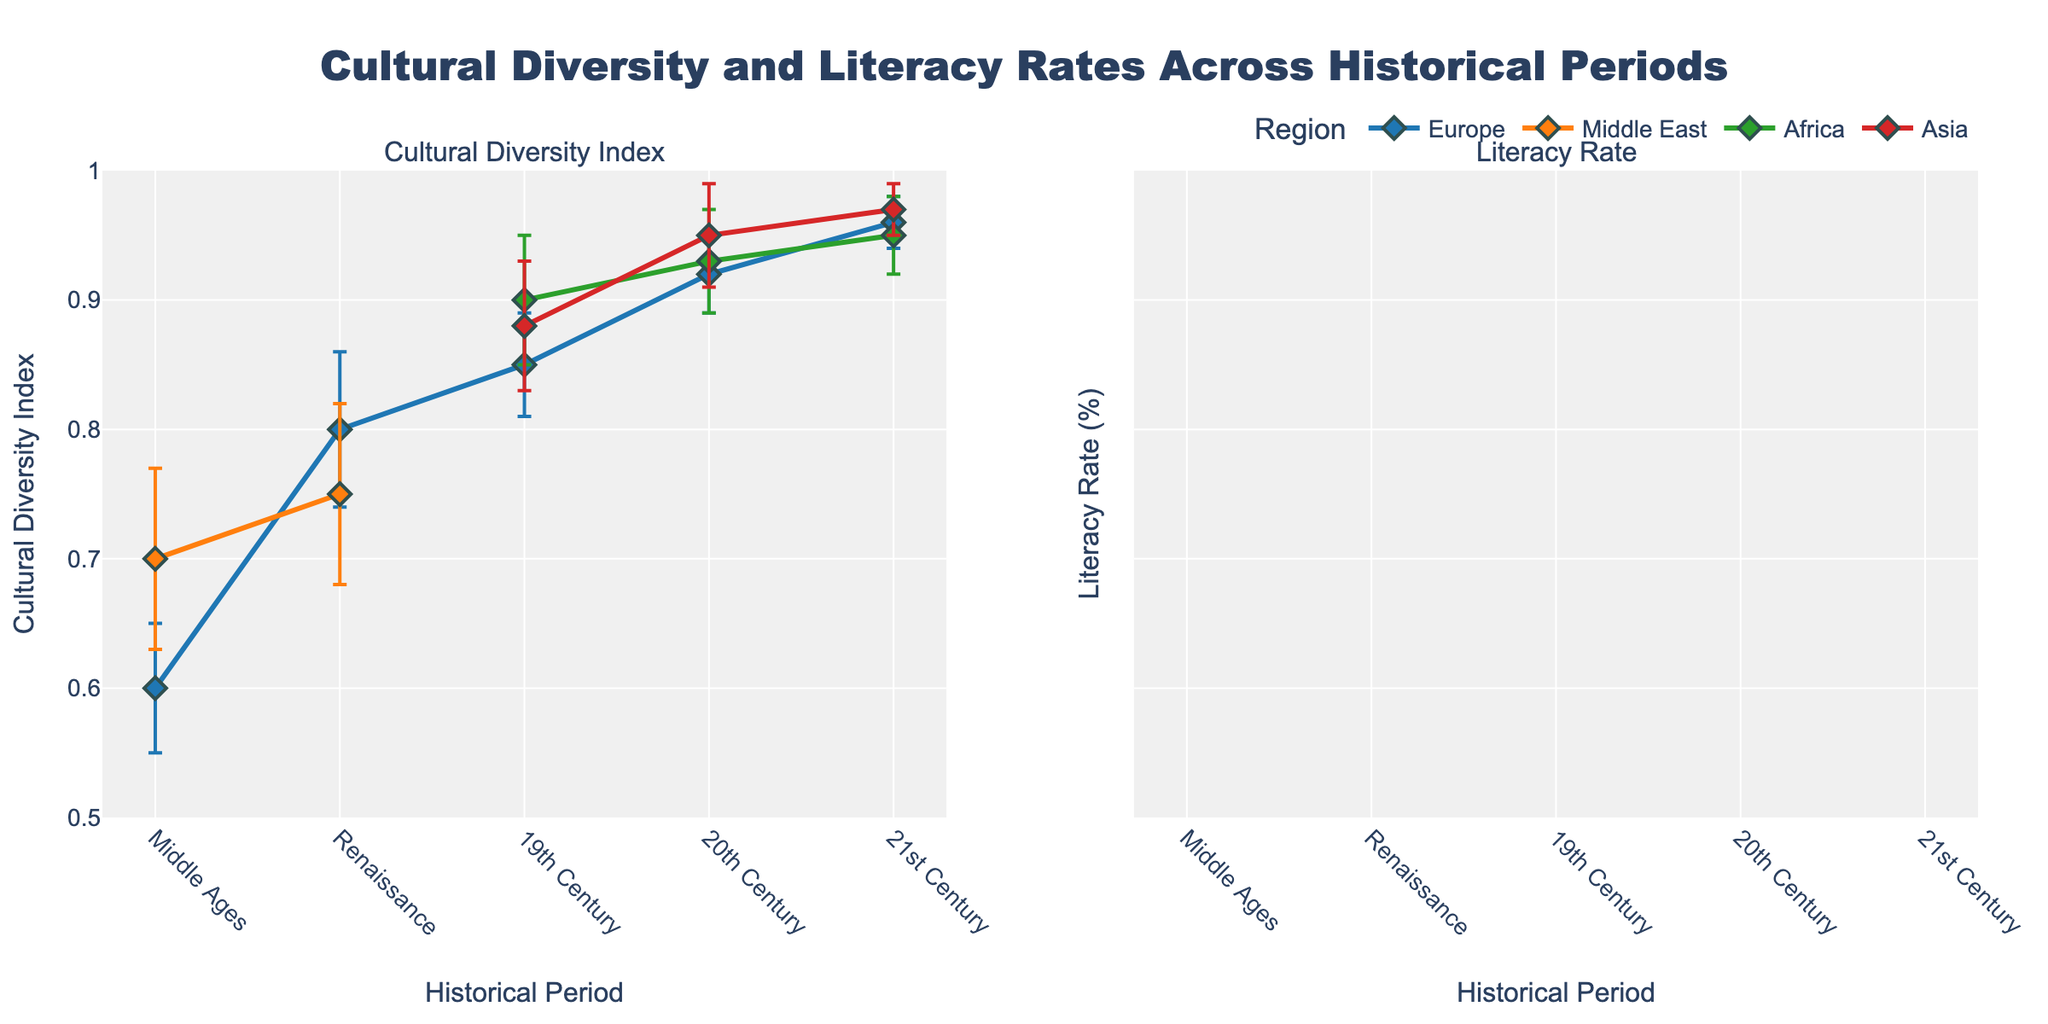Which historical period shows the highest Cultural Diversity Index for Europe? By observing the plot on the left, find the highest point for Europe (marked with a specific color and symbol). The 21st Century shows the highest point.
Answer: 21st Century What are the literacy rates for Asia in the 19th and 20th centuries? Look at the plot on the right, identify the two data points for Asia corresponding to the 19th and 20th centuries. The values are 30% and 65%, respectively.
Answer: 30%, 65% How does the Cultural Diversity Index of the Renaissance period in the Middle East compare to Europe? Examine the left subplot; identify the points for the Renaissance period for both regions. Europe has a CDI of 0.8, and the Middle East has a CDI of 0.75, indicating Europe has a slightly higher CDI.
Answer: Europe > Middle East What is the change in literacy rate for Africa from the 19th Century to the 20th Century? On the right plot, find the literacy rates for Africa in the 19th and 20th centuries. Subtract the 19th Century value (10%) from the 20th Century value (40%) to get the change.
Answer: 30% Which region has the highest error margin for the Literacy Rate in the 21st Century? In the right subplot, check the error bars for all regions in the 21st Century. Asia's error margin is the largest at 7.5.
Answer: Asia What is the average Cultural Diversity Index for Europe across all historical periods? Identify Europe's CDI values across all periods (0.6, 0.8, 0.85, 0.92, and 0.96). Calculate the average: (0.6 + 0.8 + 0.85 + 0.92 + 0.96) / 5.
Answer: 0.826 In which period did Asia show the greatest increase in literacy rate? On the right plot, track Asia's literacy rate across periods. The most significant increase is from the 20th Century (65%) to the 21st Century (85%).
Answer: 20th to 21st Century How many regions are represented in the 19th Century for both subplots? On both plots, observe the number of unique data points for the 19th Century. Each subplot includes Europe, Africa, and Asia, making three regions.
Answer: 3 regions What is the difference in the Cultural Diversity Index between Africa and Asia in the 20th Century? On the left subplot, compare the CDI values of Africa (0.93) and Asia (0.95) in the 20th Century. Subtract Africa's value from Asia's value.
Answer: 0.02 Which historical period has the highest overall Literacy Rate for all regions? In the right subplot, find the period where the highest literacy rate value is observed. The highest rate is 99% in the 21st Century for Europe.
Answer: 21st Century 